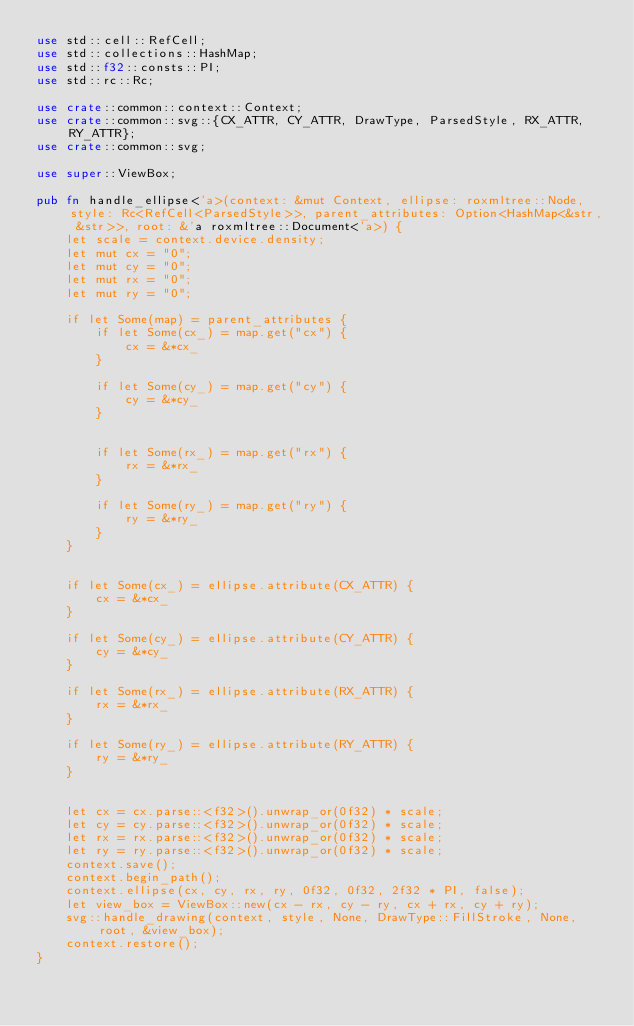<code> <loc_0><loc_0><loc_500><loc_500><_Rust_>use std::cell::RefCell;
use std::collections::HashMap;
use std::f32::consts::PI;
use std::rc::Rc;

use crate::common::context::Context;
use crate::common::svg::{CX_ATTR, CY_ATTR, DrawType, ParsedStyle, RX_ATTR, RY_ATTR};
use crate::common::svg;

use super::ViewBox;

pub fn handle_ellipse<'a>(context: &mut Context, ellipse: roxmltree::Node, style: Rc<RefCell<ParsedStyle>>, parent_attributes: Option<HashMap<&str, &str>>, root: &'a roxmltree::Document<'a>) {
    let scale = context.device.density;
    let mut cx = "0";
    let mut cy = "0";
    let mut rx = "0";
    let mut ry = "0";

    if let Some(map) = parent_attributes {
        if let Some(cx_) = map.get("cx") {
            cx = &*cx_
        }

        if let Some(cy_) = map.get("cy") {
            cy = &*cy_
        }


        if let Some(rx_) = map.get("rx") {
            rx = &*rx_
        }

        if let Some(ry_) = map.get("ry") {
            ry = &*ry_
        }
    }


    if let Some(cx_) = ellipse.attribute(CX_ATTR) {
        cx = &*cx_
    }

    if let Some(cy_) = ellipse.attribute(CY_ATTR) {
        cy = &*cy_
    }

    if let Some(rx_) = ellipse.attribute(RX_ATTR) {
        rx = &*rx_
    }

    if let Some(ry_) = ellipse.attribute(RY_ATTR) {
        ry = &*ry_
    }


    let cx = cx.parse::<f32>().unwrap_or(0f32) * scale;
    let cy = cy.parse::<f32>().unwrap_or(0f32) * scale;
    let rx = rx.parse::<f32>().unwrap_or(0f32) * scale;
    let ry = ry.parse::<f32>().unwrap_or(0f32) * scale;
    context.save();
    context.begin_path();
    context.ellipse(cx, cy, rx, ry, 0f32, 0f32, 2f32 * PI, false);
    let view_box = ViewBox::new(cx - rx, cy - ry, cx + rx, cy + ry);
    svg::handle_drawing(context, style, None, DrawType::FillStroke, None, root, &view_box);
    context.restore();
}
</code> 